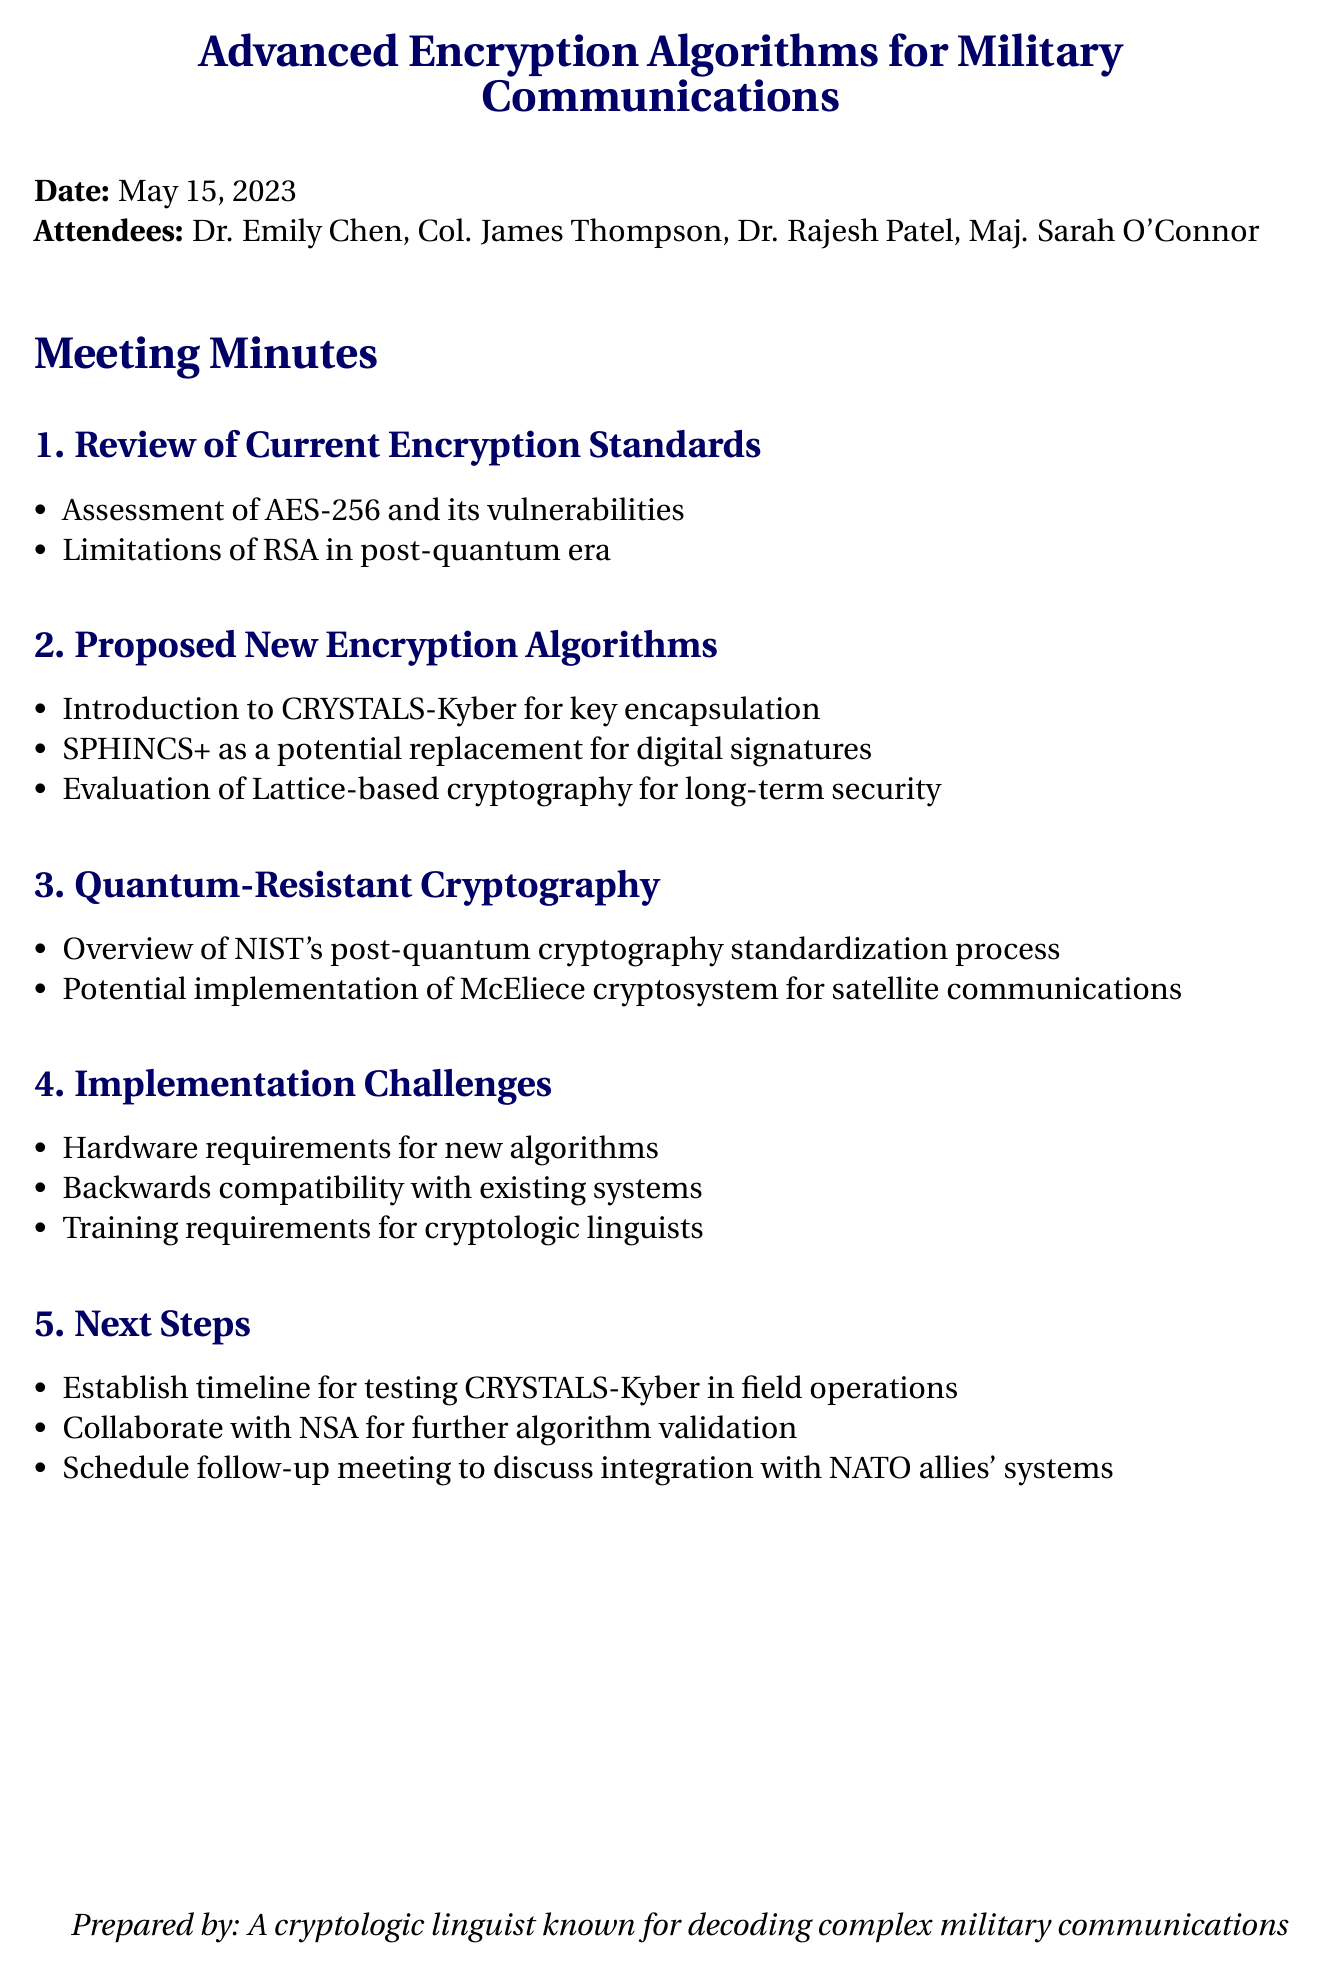What is the date of the meeting? The date of the meeting is stated in the document.
Answer: May 15, 2023 Who is the Lead Cryptologist? The document lists the attendees and their roles, including the Lead Cryptologist.
Answer: Dr. Emily Chen What algorithm is introduced for key encapsulation? The section on proposed new encryption algorithms mentions a specific algorithm for key encapsulation.
Answer: CRYSTALS-Kyber What challenge is related to existing systems? This query addresses the implementation challenges discussed in the meeting minutes, specifically regarding compatibility.
Answer: Backwards compatibility with existing systems How many attendees were present? The total number of attendees is indicated in the introductory section of the document.
Answer: Four What is the purpose of the potential implementation of the McEliece cryptosystem? This question requires reasoning about the purpose stated for a specific cryptographic system within the document.
Answer: Satellite communications What will be established for testing CRYSTALS-Kyber? The next steps section outlines specific actions to be taken regarding CRYSTALS-Kyber.
Answer: Timeline Which encryption method is suggested to replace digital signatures? The description of proposed new algorithms includes options for digital signatures.
Answer: SPHINCS+ Who is responsible for further algorithm validation? The document discusses collaboration with a specific organization for validation of encryption algorithms.
Answer: NSA 